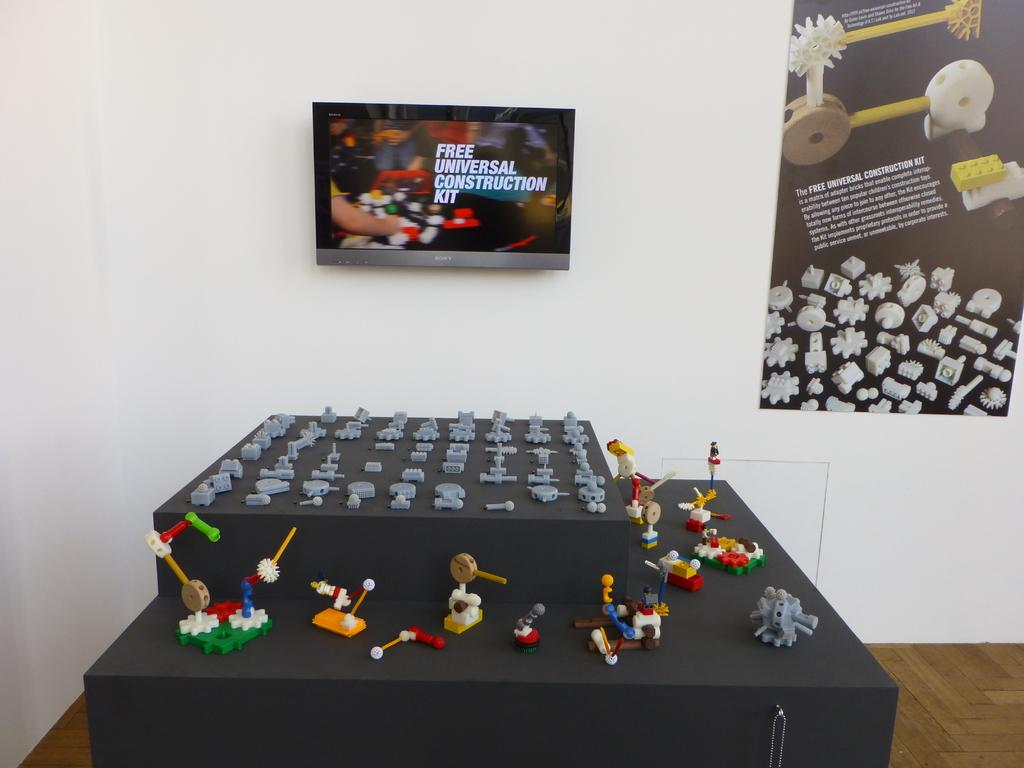<image>
Share a concise interpretation of the image provided. A table with small figures on display and an ad that says Free Universal Construction Kit. 